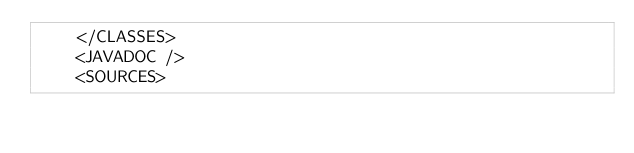Convert code to text. <code><loc_0><loc_0><loc_500><loc_500><_XML_>    </CLASSES>
    <JAVADOC />
    <SOURCES></code> 